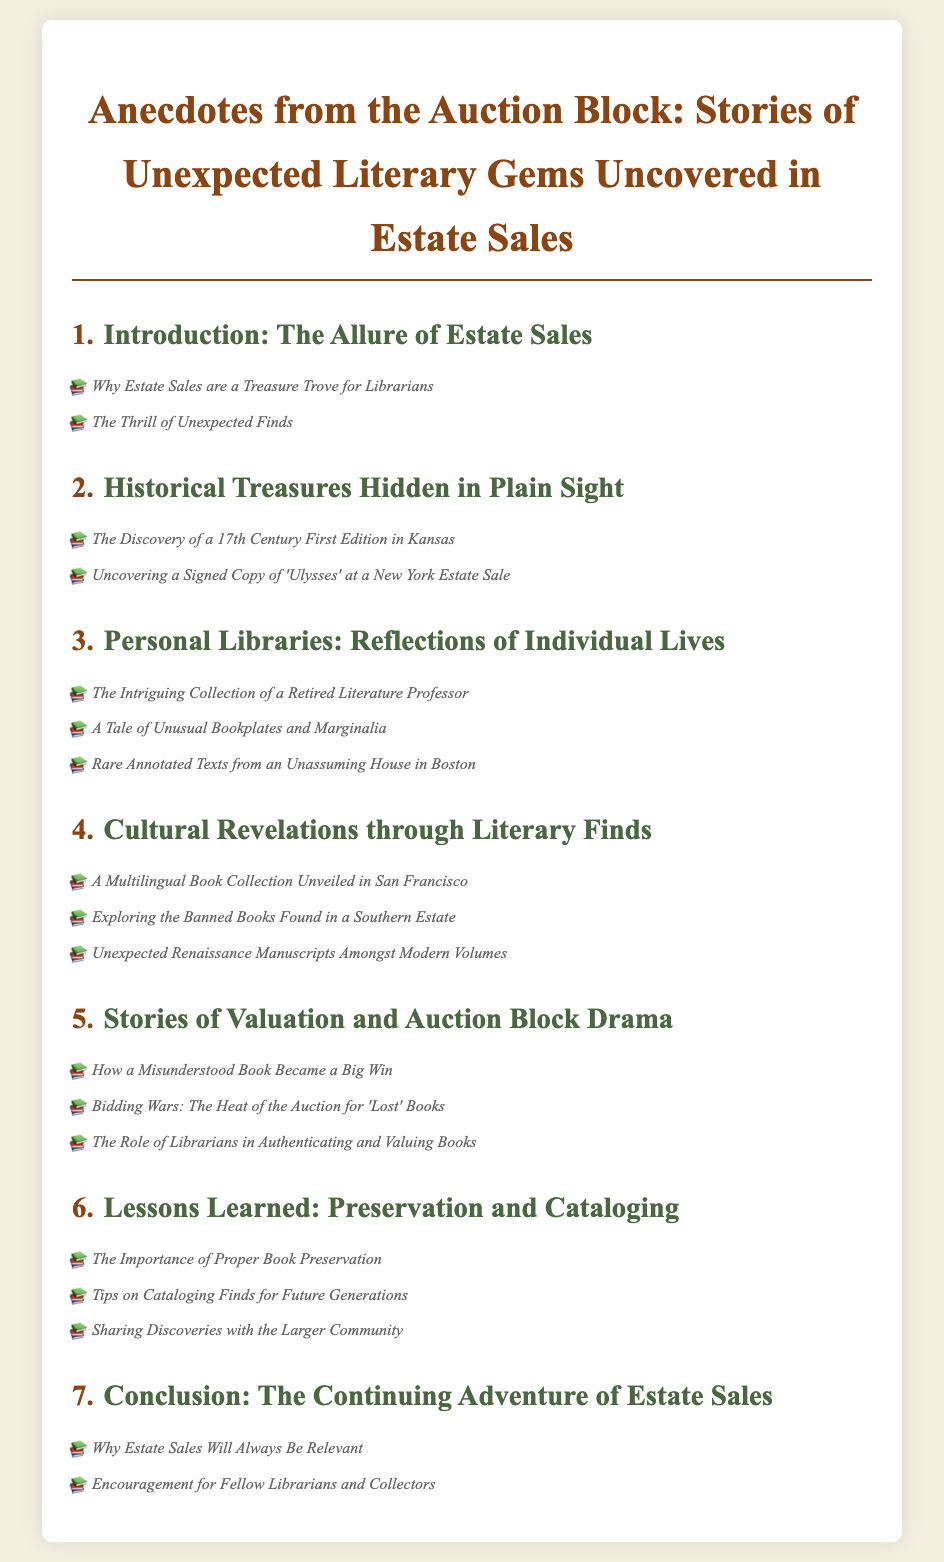What is the title of the document? The title is presented in the header of the document, which is "Anecdotes from the Auction Block: Stories of Unexpected Literary Gems Uncovered in Estate Sales."
Answer: Anecdotes from the Auction Block: Stories of Unexpected Literary Gems Uncovered in Estate Sales How many sections are in Chapter 3? The number of sections in Chapter 3 can be counted, which are three: "The Intriguing Collection of a Retired Literature Professor," "A Tale of Unusual Bookplates and Marginalia," and "Rare Annotated Texts from an Unassuming House in Boston."
Answer: 3 Which city is mentioned in relation to a signed copy of 'Ulysses'? The city associated with the signed copy of 'Ulysses' can be found in the corresponding section of Chapter 2.
Answer: New York What is the first section in Chapter 5? The first section is listed in Chapter 5 as "How a Misunderstood Book Became a Big Win."
Answer: How a Misunderstood Book Became a Big Win Which chapter focuses on personal libraries? Chapter 3 is dedicated to the theme of personal libraries and their reflections of individual lives.
Answer: 3 What is the last section in the document? The last section is mentioned in Chapter 7, covering the conclusion of the document.
Answer: Encouragement for Fellow Librarians and Collectors How many chapters are there in total? The total number of chapters can be counted from the Table of Contents, which includes seven chapters.
Answer: 7 In which chapter is the preservation of books discussed? The discussion on preservation can be found in Chapter 6, specifically addressing preservation and cataloging lessons learned.
Answer: Chapter 6 